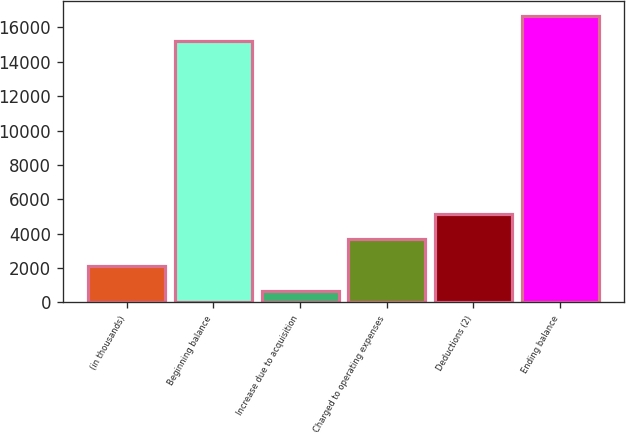Convert chart. <chart><loc_0><loc_0><loc_500><loc_500><bar_chart><fcel>(in thousands)<fcel>Beginning balance<fcel>Increase due to acquisition<fcel>Charged to operating expenses<fcel>Deductions (2)<fcel>Ending balance<nl><fcel>2119.1<fcel>15225<fcel>662<fcel>3673<fcel>5130.1<fcel>16682.1<nl></chart> 